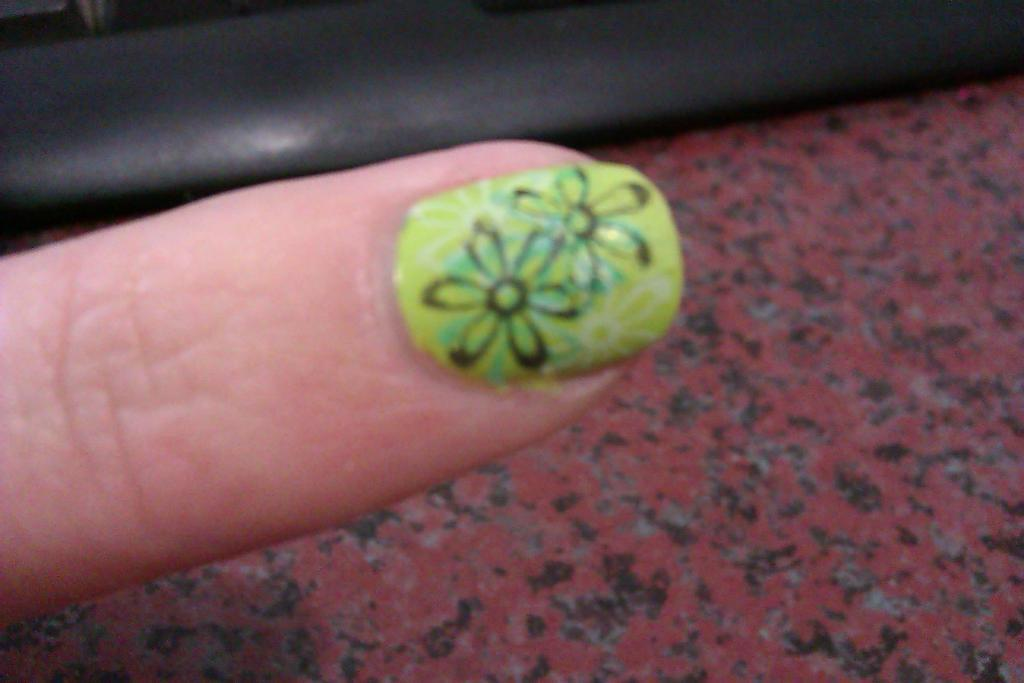What is the main subject of the image? The main subject of the image is a finger. Can you describe the appearance of the finger? The finger has nail paint. What is the background or surface in the image? There is a surface at the bottom of the image. What type of hat is the finger wearing in the image? There is no hat present in the image; the main subject is a finger with nail paint. 